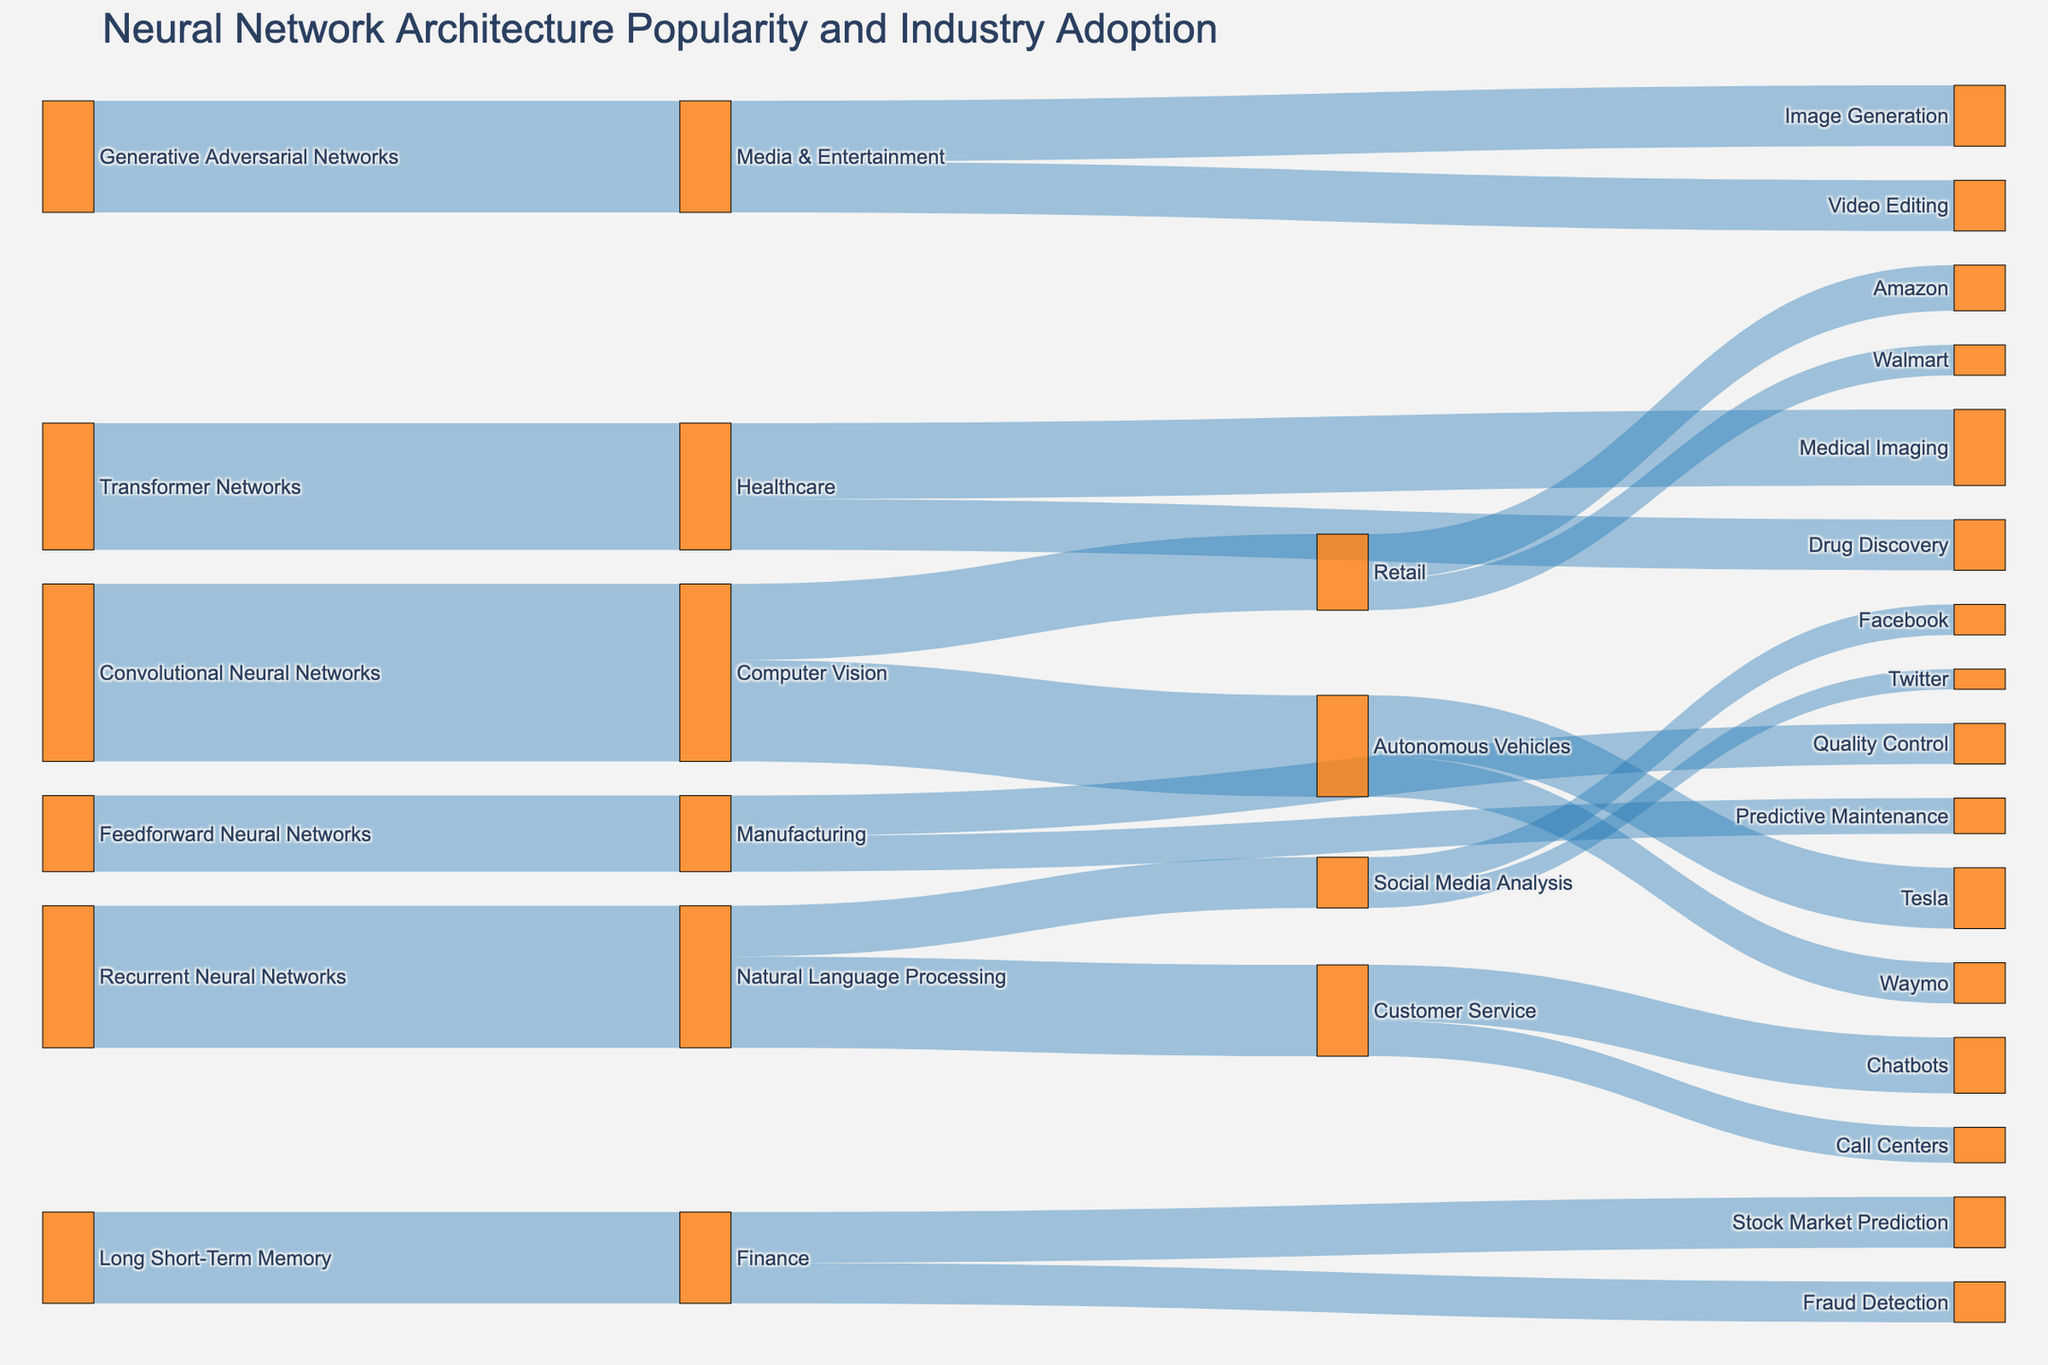What's the most adopted neural network architecture? The most adopted neural network architecture is the one with the highest total 'Value' across all its connections to various industries. The 'Convolutional Neural Networks' connected to 'Computer Vision' have the highest value of 35, making it the most adopted.
Answer: Convolutional Neural Networks What is the adoption rate of Transformer Networks in the Healthcare industry? By looking at the "Transformer Networks" source node and tracing its flow to the "Healthcare" target node, you can see that the value is 25.
Answer: 25 How many industries use Recurrent Neural Networks? Find all target nodes connected to "Recurrent Neural Networks." The industries are 'Natural Language Processing,' totalling one.
Answer: 1 Which industry has the least number of connections? Examine each industry (target nodes) and count how many source nodes are connected to it. 'Manufacturing' has two connections ('Feedforward Neural Networks' -> 'Manufacturing' and 'Manufacturing' -> 'Quality Control,' 'Predictive Maintenance'), which is the least among others.
Answer: Manufacturing Compare the adoption rates of Long Short-Term Memory in Finance and Healthcare. Which one is higher? Long Short-Term Memory is connected to 'Finance' with a value of 18 and 'Healthcare' with no connection. Thus, the adoption rate in Finance is higher.
Answer: Finance What is the total value for the applications within Media & Entertainment? Add the values for 'Image Generation' (12) and 'Video Editing' (10). The total is 12 + 10 = 22.
Answer: 22 Which specific application within Customer Service has a higher value, Chatbots or Call Centers? Compare the values for 'Chatbots' and 'Call Centers' under Customer Service. Chatbots have a value of 11, while Call Centers have 7.
Answer: Chatbots How does the adoption of Convolutional Neural Networks in Computer Vision compare to its adoption in Retail? Convolutional Neural Networks in 'Computer Vision' have a value of 35. For applications in 'Retail,' we look at 'Computer Vision' -> 'Retail' with a value of 15. 35 (Computer Vision) is greater than 15 (Retail).
Answer: Computer Vision What is the combined adoption value for neural networks in the finance industry? Sum the values from 'Finance' to its applications: 'Fraud Detection' (8) and 'Stock Market Prediction' (10). The combined value is 8 + 10 = 18.
Answer: 18 How many units of value are transferred from Autonomous Vehicles to Tesla? Find the value that flows from 'Autonomous Vehicles' to 'Tesla.' The value is 12.
Answer: 12 